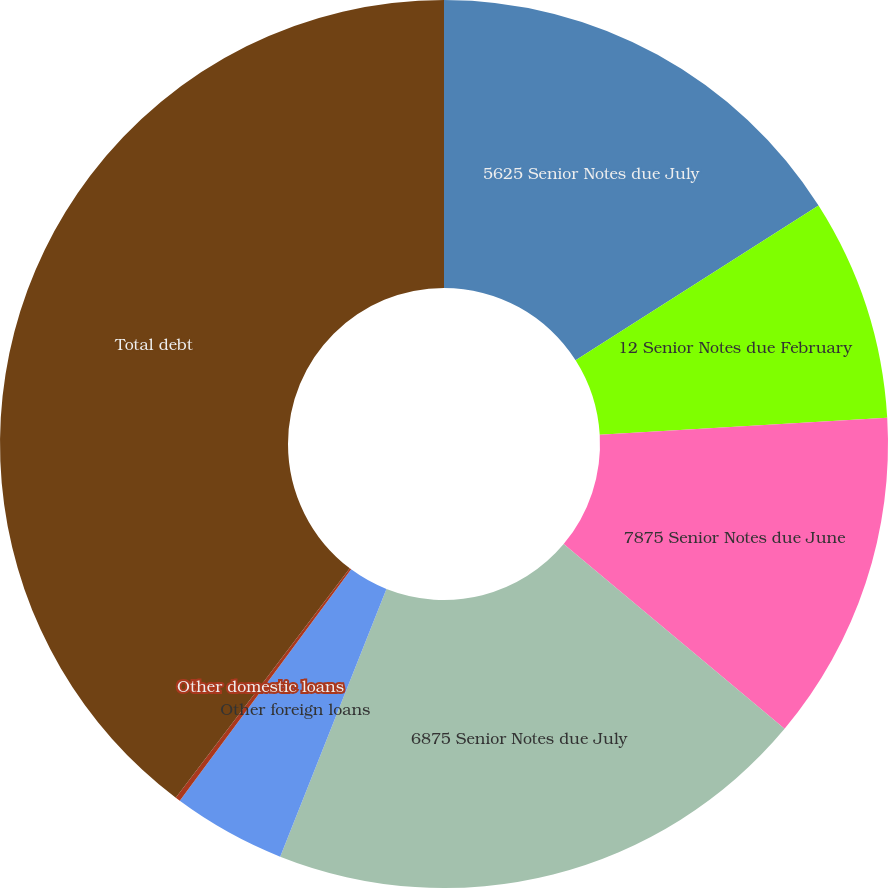Convert chart. <chart><loc_0><loc_0><loc_500><loc_500><pie_chart><fcel>5625 Senior Notes due July<fcel>12 Senior Notes due February<fcel>7875 Senior Notes due June<fcel>6875 Senior Notes due July<fcel>Other foreign loans<fcel>Other domestic loans<fcel>Total debt<nl><fcel>15.98%<fcel>8.08%<fcel>12.03%<fcel>19.93%<fcel>4.13%<fcel>0.18%<fcel>39.68%<nl></chart> 